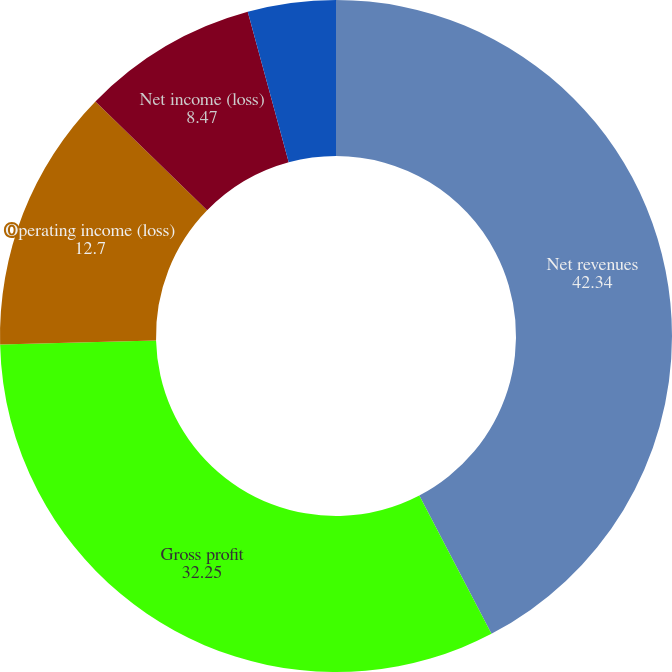Convert chart to OTSL. <chart><loc_0><loc_0><loc_500><loc_500><pie_chart><fcel>Net revenues<fcel>Gross profit<fcel>Operating income (loss)<fcel>Net income (loss)<fcel>Net income (loss) per share -<nl><fcel>42.34%<fcel>32.25%<fcel>12.7%<fcel>8.47%<fcel>4.23%<nl></chart> 